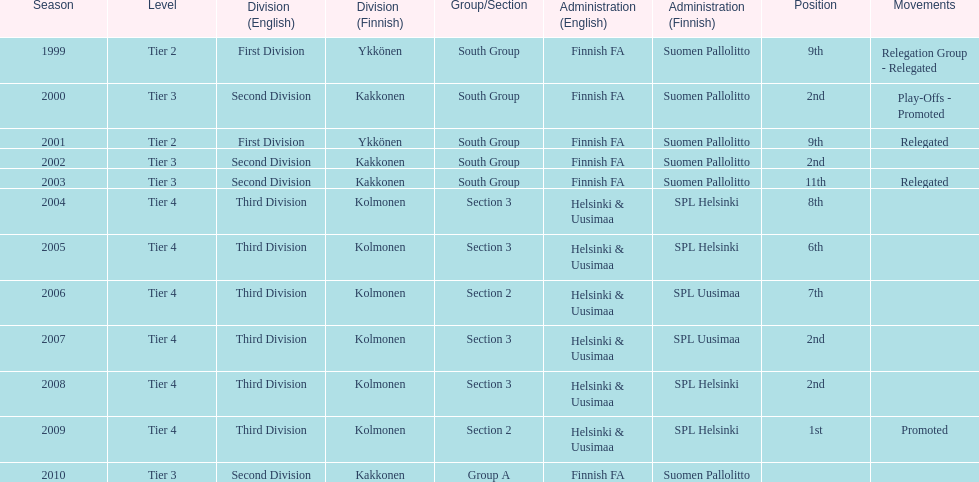How many times has this team been relegated? 3. 